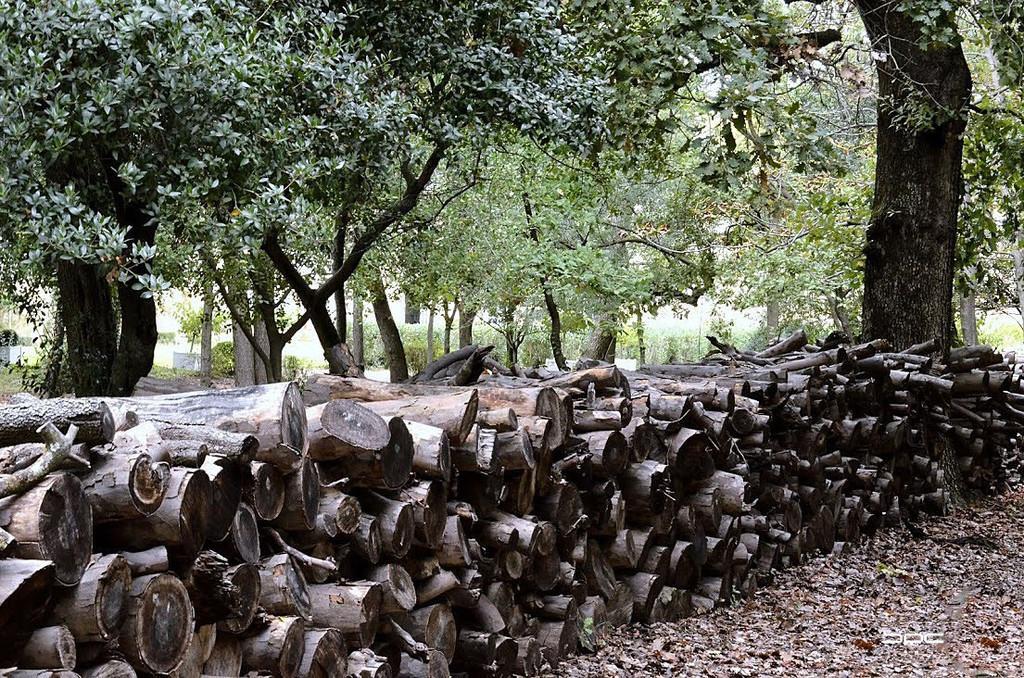In one or two sentences, can you explain what this image depicts? In this picture we can see wooden logs and dried leaves on the ground. In the background we can see plants and trees. 